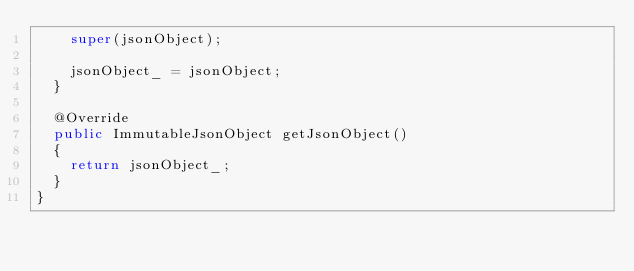<code> <loc_0><loc_0><loc_500><loc_500><_Java_>    super(jsonObject);
    
    jsonObject_ = jsonObject;
  }

  @Override
  public ImmutableJsonObject getJsonObject()
  {
    return jsonObject_;
  }
}
</code> 